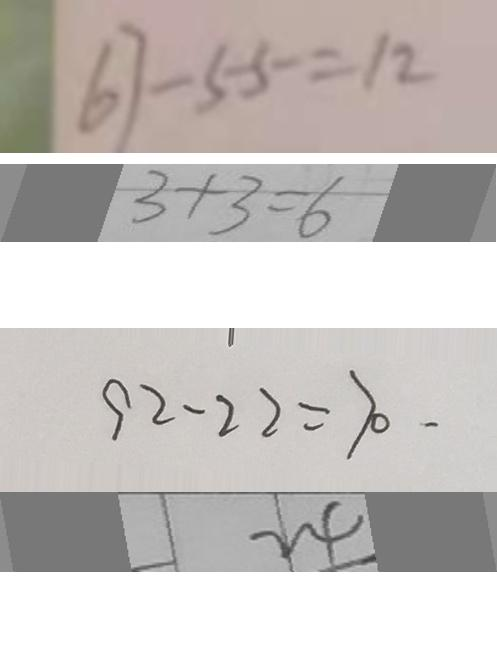<formula> <loc_0><loc_0><loc_500><loc_500>6 7 - 5 5 = 1 2 
 3 + 3 = 6 
 9 2 - 2 2 = 7 0 . 
 2 4</formula> 